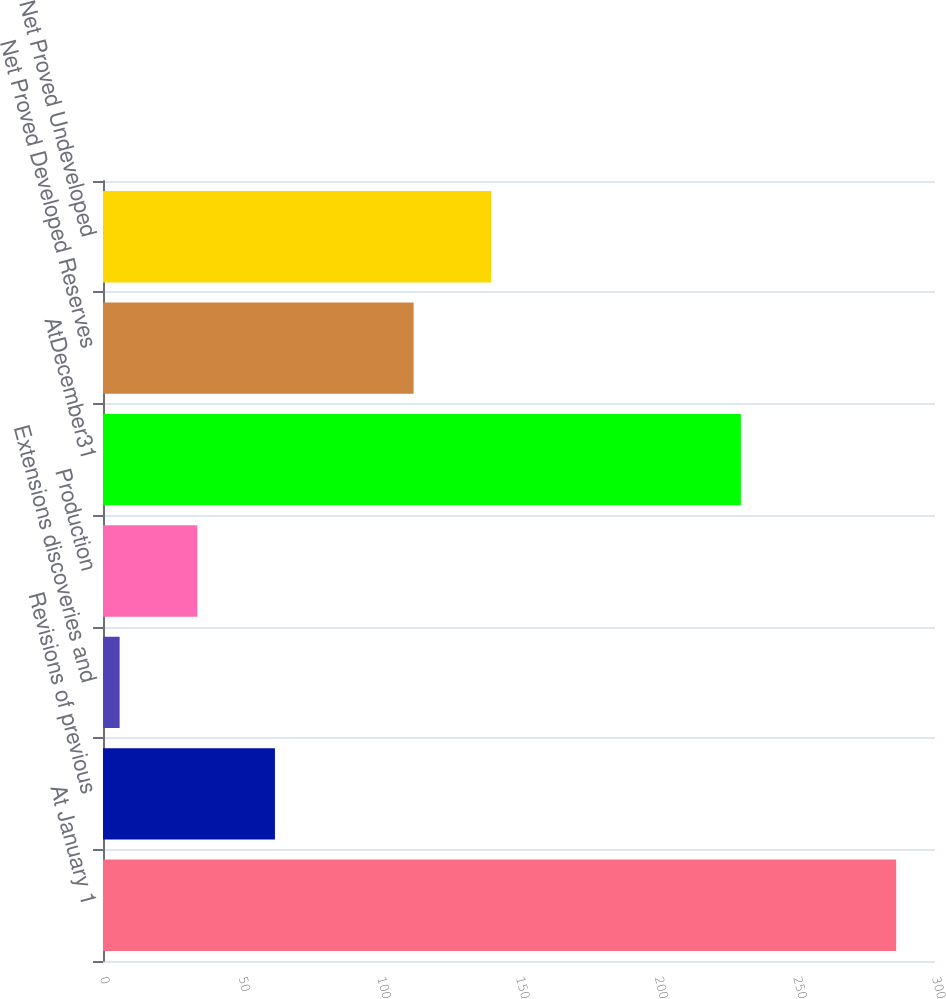Convert chart. <chart><loc_0><loc_0><loc_500><loc_500><bar_chart><fcel>At January 1<fcel>Revisions of previous<fcel>Extensions discoveries and<fcel>Production<fcel>AtDecember31<fcel>Net Proved Developed Reserves<fcel>Net Proved Undeveloped<nl><fcel>286<fcel>62<fcel>6<fcel>34<fcel>230<fcel>112<fcel>140<nl></chart> 